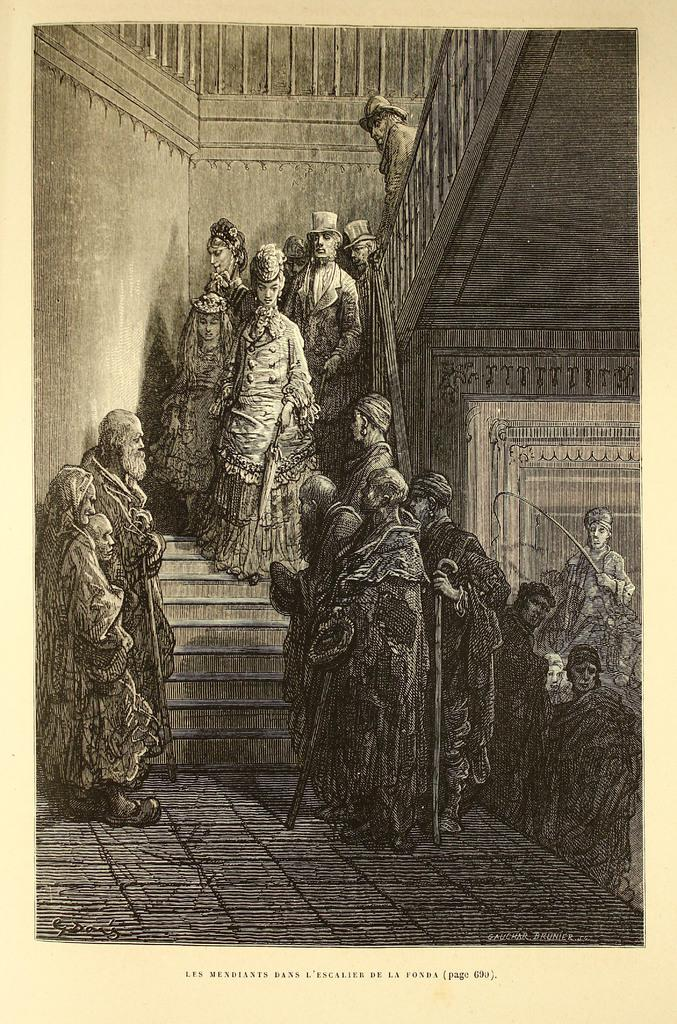What type of image is being described? The image is a black and white photography. What can be seen on the floor in the image? There are persons standing on the floor. What are some of the persons doing in the image? Some persons are climbing the stairs. What type of grass is present in the image? There is no grass present in the image; it is a black and white photography of persons standing and climbing stairs. 